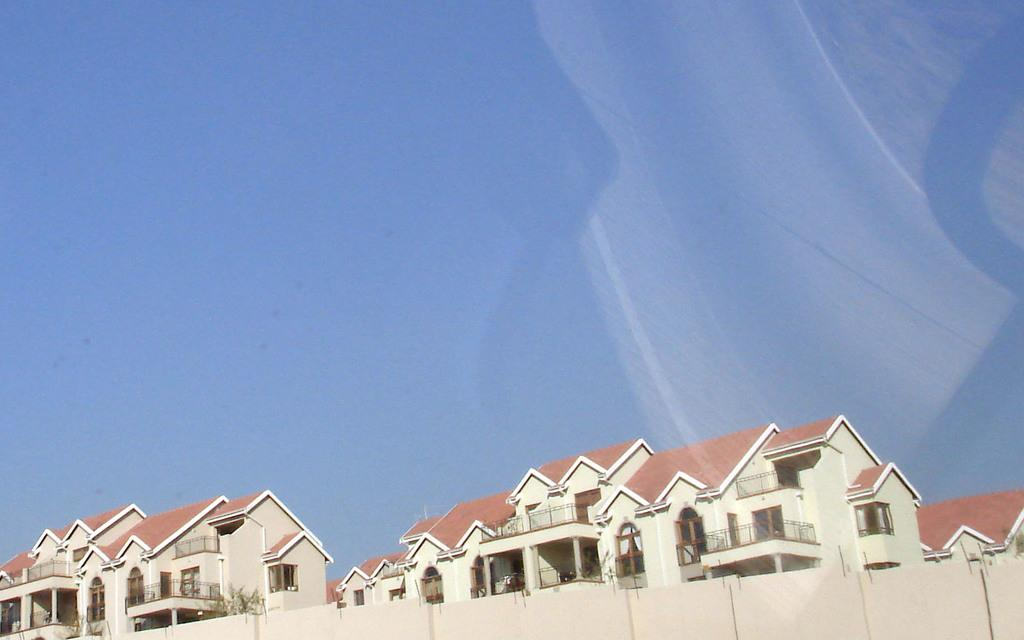What type of structures can be seen in the image? There are houses in the image. What other elements are present in the image besides the houses? There are plants in the image. What type of food is being served on the table in the image? There is no table or food present in the image; it only features houses and plants. Can you see a cub playing with a tail in the image? There is no cub or tail present in the image; it only features houses and plants. 